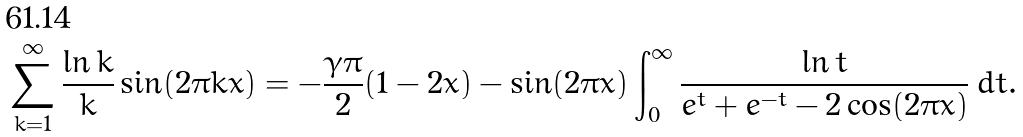<formula> <loc_0><loc_0><loc_500><loc_500>\sum _ { k = 1 } ^ { \infty } \frac { \ln k } { k } \sin ( { 2 \pi k x } ) = - \frac { \gamma \pi } { 2 } ( 1 - 2 x ) - \sin ( 2 \pi x ) \int _ { 0 } ^ { \infty } \frac { \ln t } { e ^ { t } + e ^ { - t } - 2 \cos ( 2 \pi x ) } \, d t .</formula> 